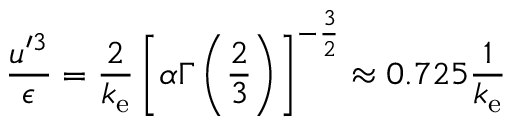<formula> <loc_0><loc_0><loc_500><loc_500>\frac { u ^ { \prime 3 } } { \epsilon } = \frac { 2 } { k _ { e } } \left [ \alpha \Gamma \left ( \frac { 2 } { 3 } \right ) \right ] ^ { - \frac { 3 } { 2 } } \approx 0 . 7 2 5 \frac { 1 } { k _ { e } }</formula> 